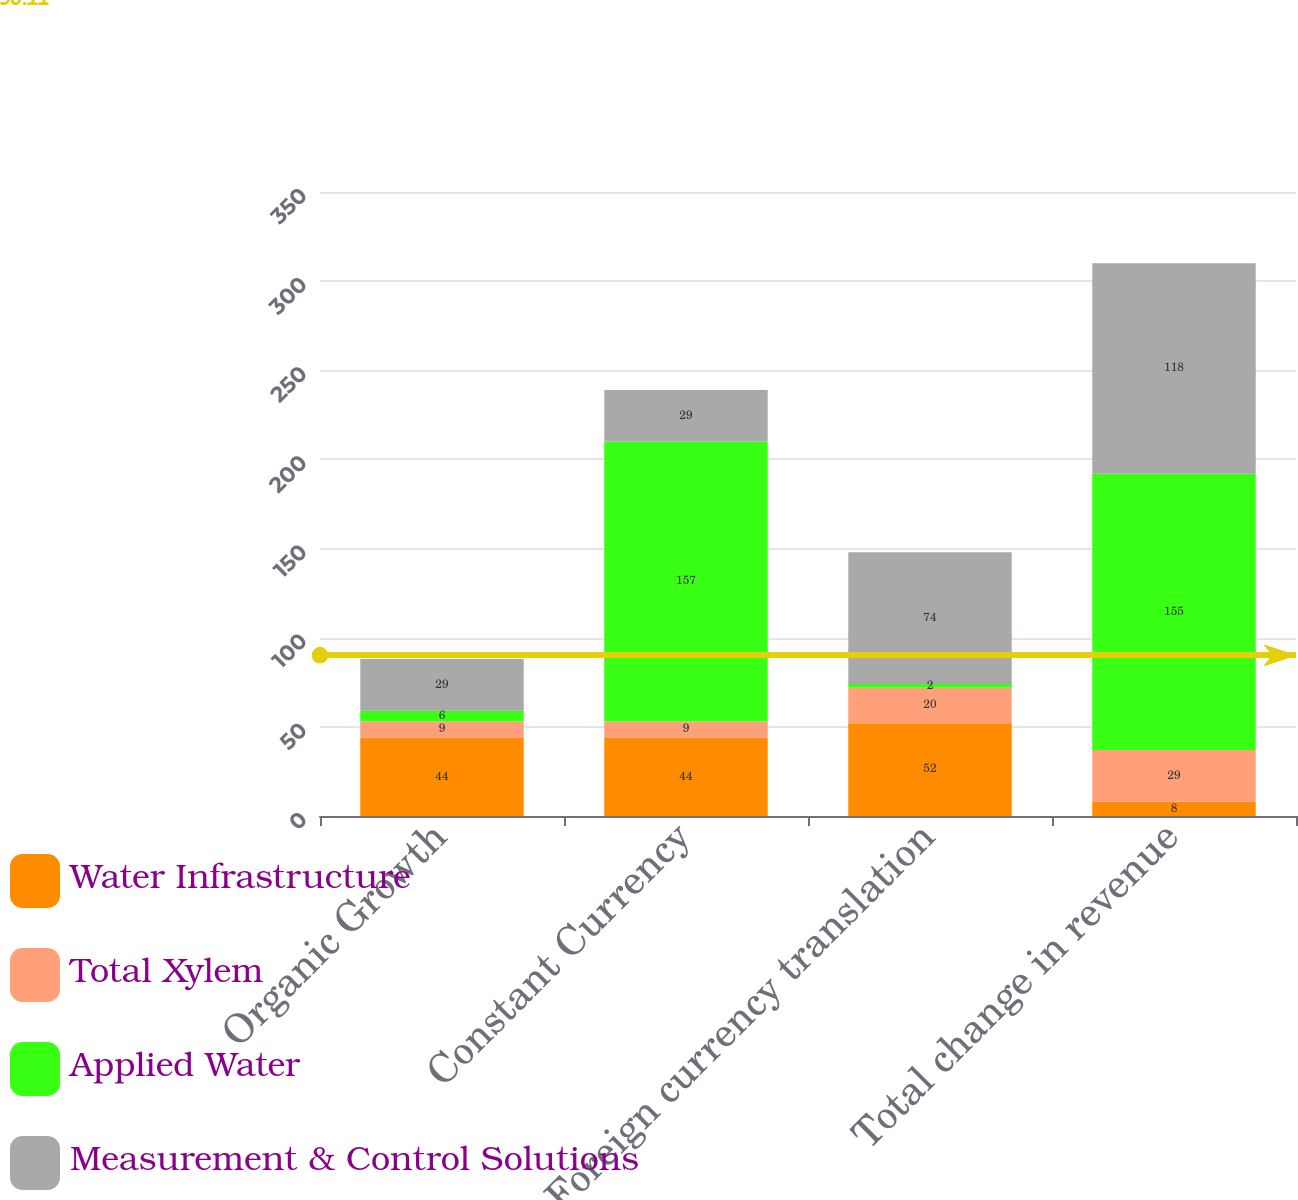Convert chart. <chart><loc_0><loc_0><loc_500><loc_500><stacked_bar_chart><ecel><fcel>Organic Growth<fcel>Constant Currency<fcel>Foreign currency translation<fcel>Total change in revenue<nl><fcel>Water Infrastructure<fcel>44<fcel>44<fcel>52<fcel>8<nl><fcel>Total Xylem<fcel>9<fcel>9<fcel>20<fcel>29<nl><fcel>Applied Water<fcel>6<fcel>157<fcel>2<fcel>155<nl><fcel>Measurement & Control Solutions<fcel>29<fcel>29<fcel>74<fcel>118<nl></chart> 